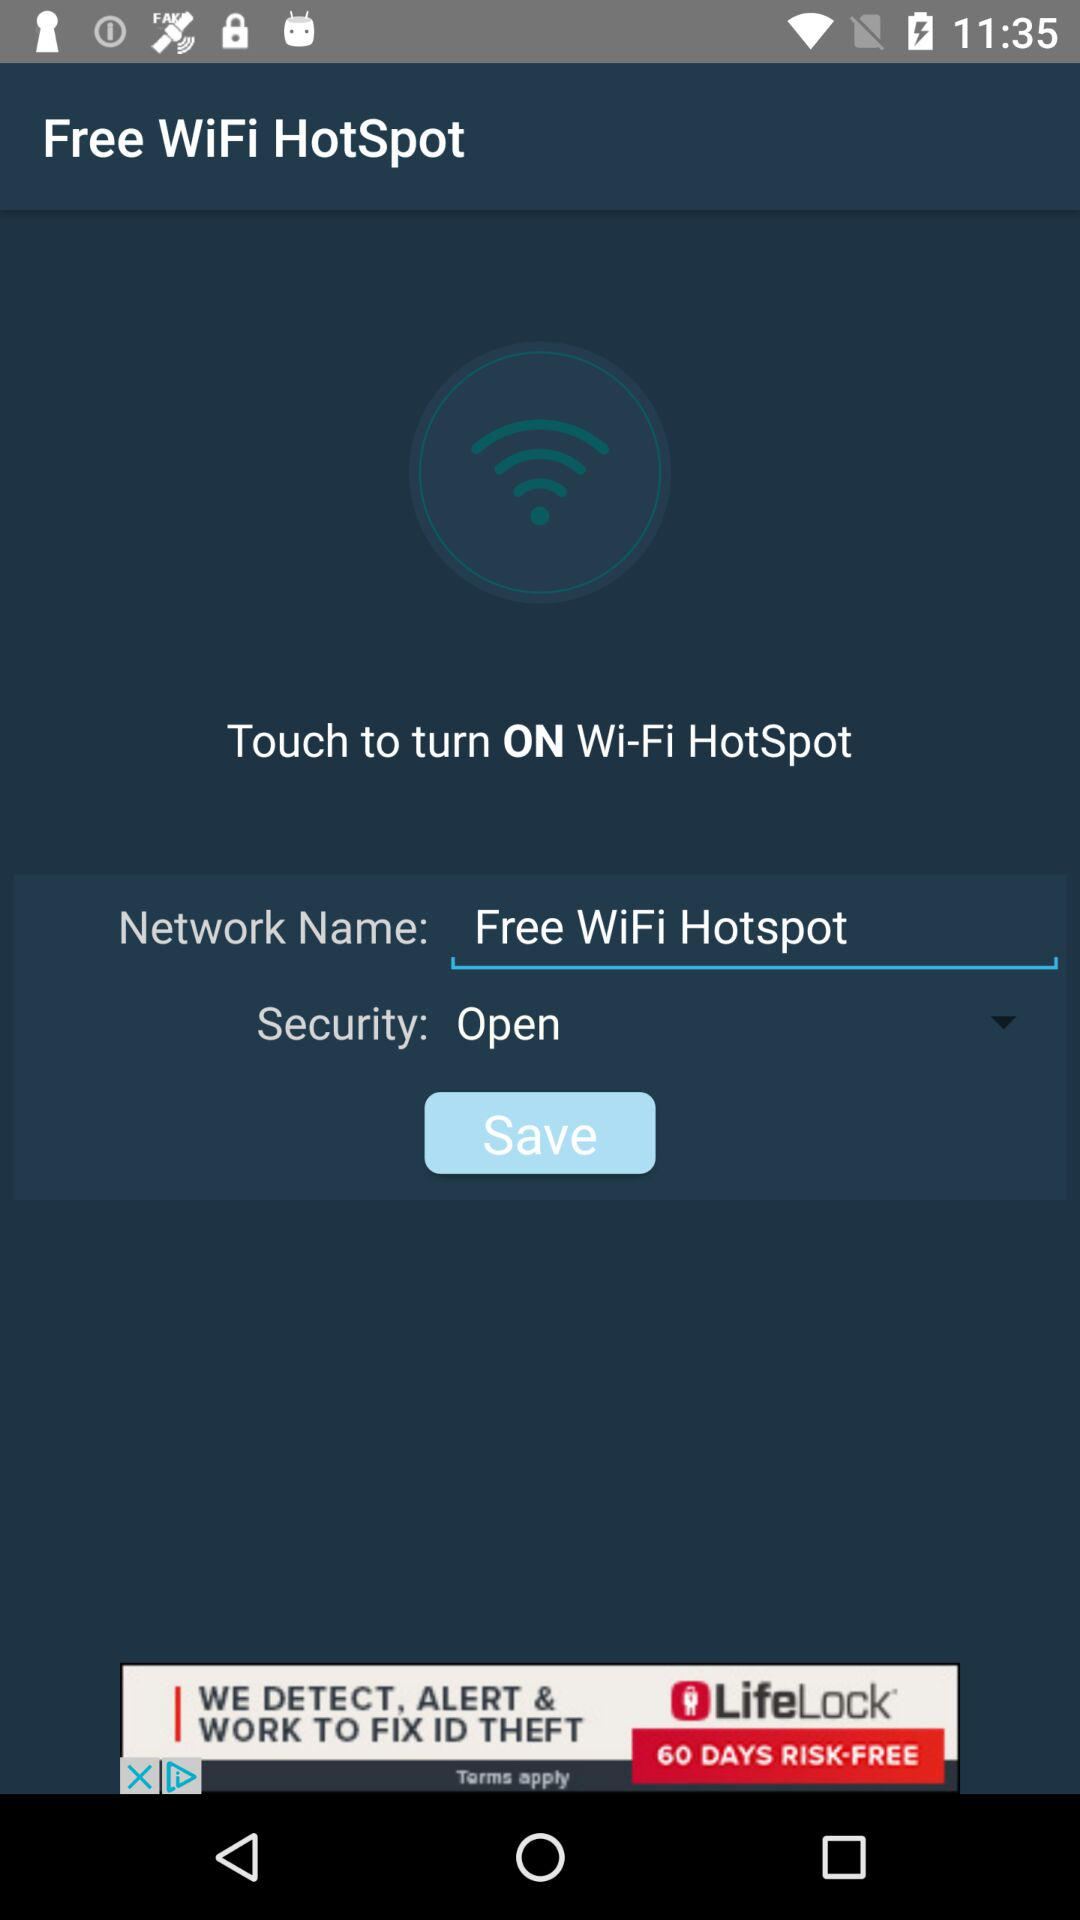What is the name of the network? The name of the network is "Free WiFi Hotspot". 